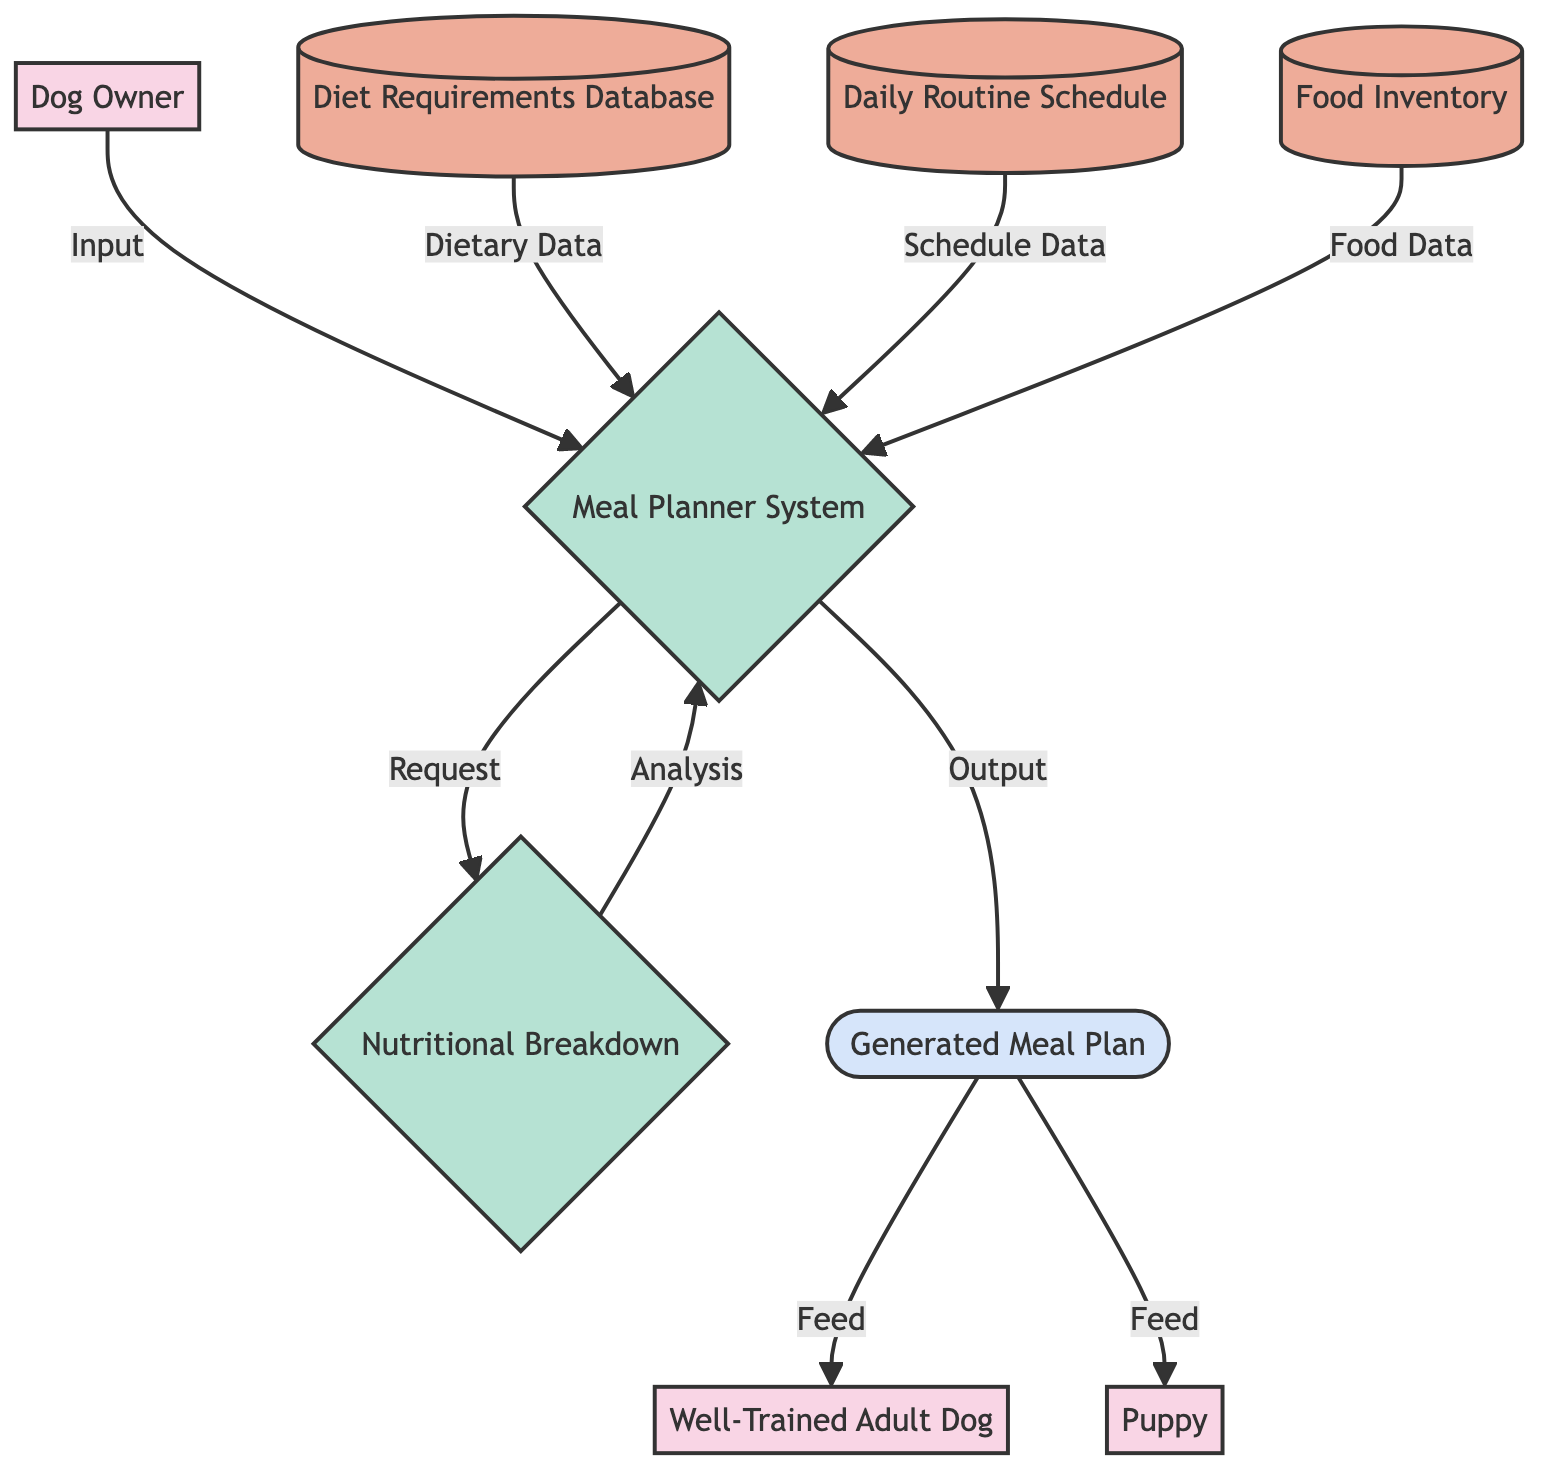What is the role of the Dog Owner? The Dog Owner is described as the individual responsible for feeding and taking care of the dog and puppy, acting as an external entity in the diagram.
Answer: The individual responsible for feeding and taking care of the dog and puppy How many external entities are present in the diagram? By counting the entities marked as external, there are three: Dog Owner, Well-Trained Adult Dog, and Puppy.
Answer: Three What type of data does the Diet Requirements Database store? The description states that it stores information regarding dietary needs, encompassing daily caloric requirements, protein, fats, and vitamins for dogs and puppies.
Answer: Dietary needs information What is the output produced by the Meal Planner System? The Meal Planner System outputs the Generated Meal Plan, which details the specific foods and quantities to give to the well-trained adult dog and the puppy.
Answer: Generated Meal Plan Which process analyzes data from both the Diet Requirements Database and Food Inventory? The Nutritional Breakdown process takes inputs from both the Diet Requirements Database and the Food Inventory to analyze nutritional information.
Answer: Nutritional Breakdown What data does the Meal Planner System request for analysis? The Meal Planner System requests analysis from the Nutritional Breakdown process, which evaluates the dietary data it received from the Diet Requirements Database and other sources.
Answer: Nutritional Breakdown How many data stores are included in the diagram? Counting the distinct data stores, there are three: Diet Requirements Database, Daily Routine Schedule, and Food Inventory.
Answer: Three What does the Generated Meal Plan feed into? The Generated Meal Plan is designed to be fed to both the Well-Trained Adult Dog and the Puppy, as indicated by the outgoing flow from the meal planner.
Answer: Well-Trained Adult Dog and Puppy What type of relationship exists between the Meal Planner System and the Diet Requirements Database? The relationship is that the Meal Planner System receives dietary data as input from the Diet Requirements Database, establishing a flow of information.
Answer: Input relationship 